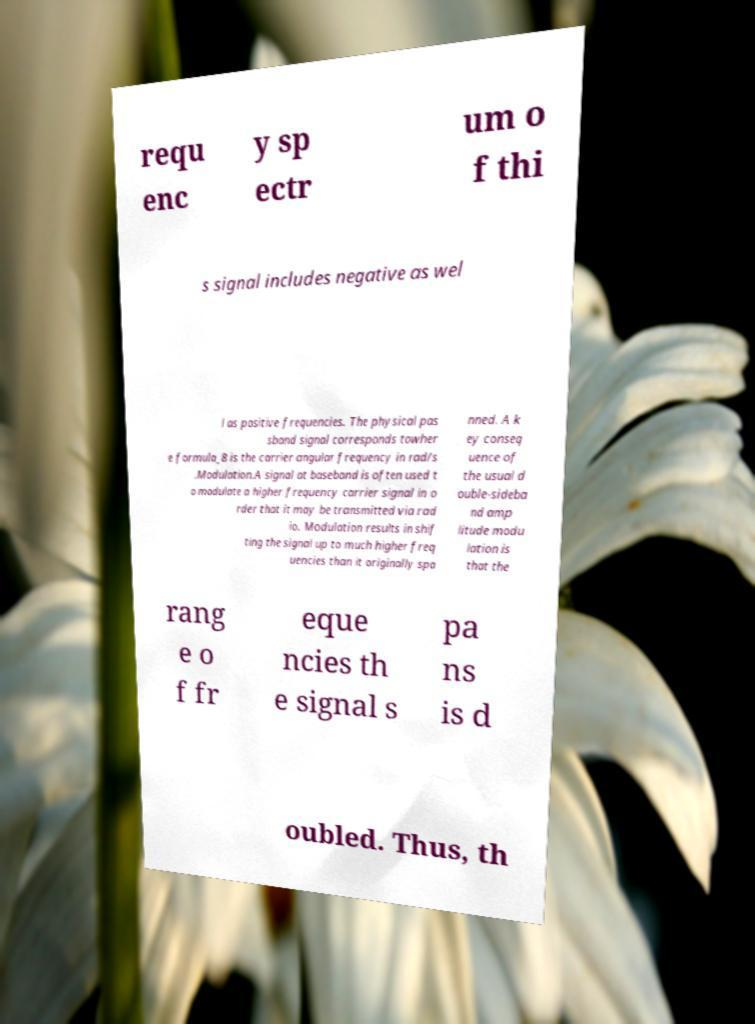There's text embedded in this image that I need extracted. Can you transcribe it verbatim? requ enc y sp ectr um o f thi s signal includes negative as wel l as positive frequencies. The physical pas sband signal corresponds towher e formula_8 is the carrier angular frequency in rad/s .Modulation.A signal at baseband is often used t o modulate a higher frequency carrier signal in o rder that it may be transmitted via rad io. Modulation results in shif ting the signal up to much higher freq uencies than it originally spa nned. A k ey conseq uence of the usual d ouble-sideba nd amp litude modu lation is that the rang e o f fr eque ncies th e signal s pa ns is d oubled. Thus, th 